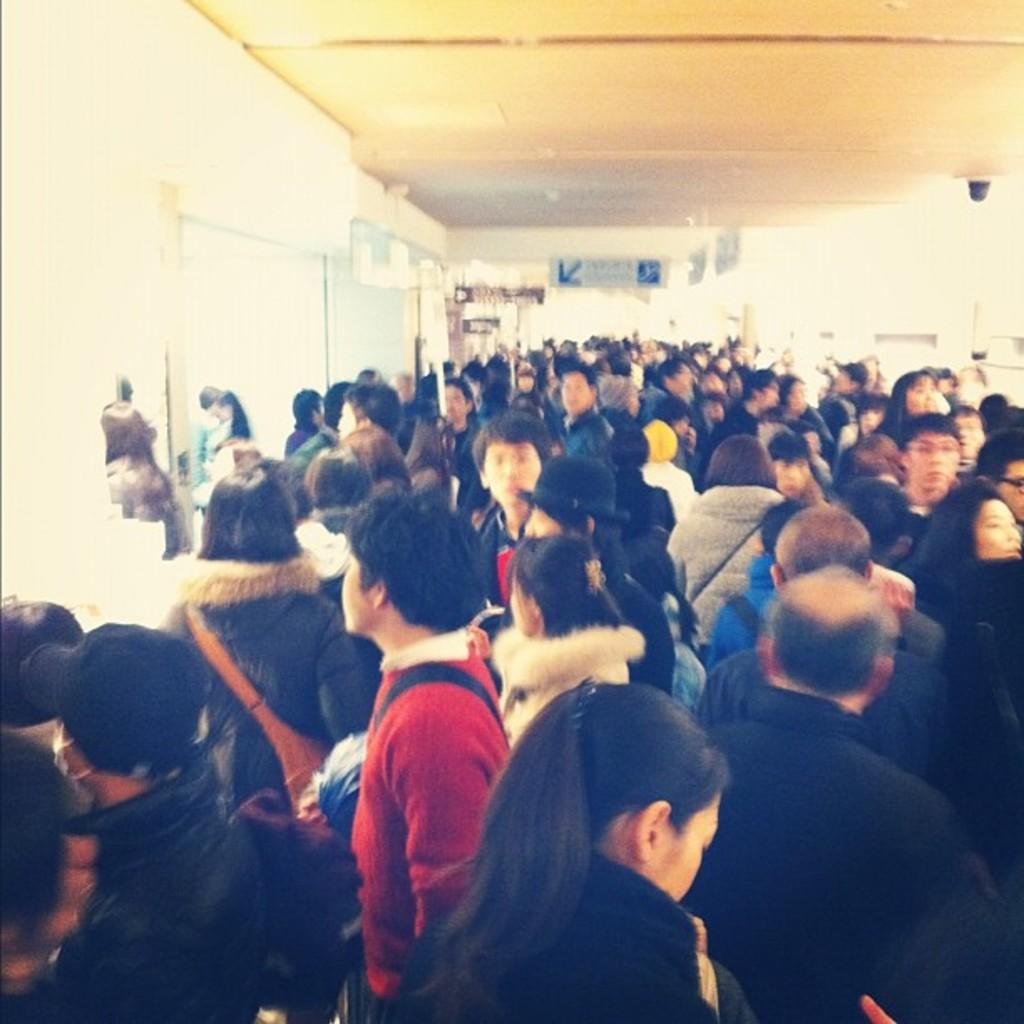How many people are in the image? There is a group of people in the image, but the exact number cannot be determined from the provided facts. What is the board used for in the image? The purpose of the board in the image cannot be determined from the provided facts. What type of structure is depicted in the image? The image contains a roof and a wall, which suggests a building or enclosed space. What type of light is being used to illuminate the fiction in the image? There is no mention of light, fiction, or any related objects or activities in the image. 